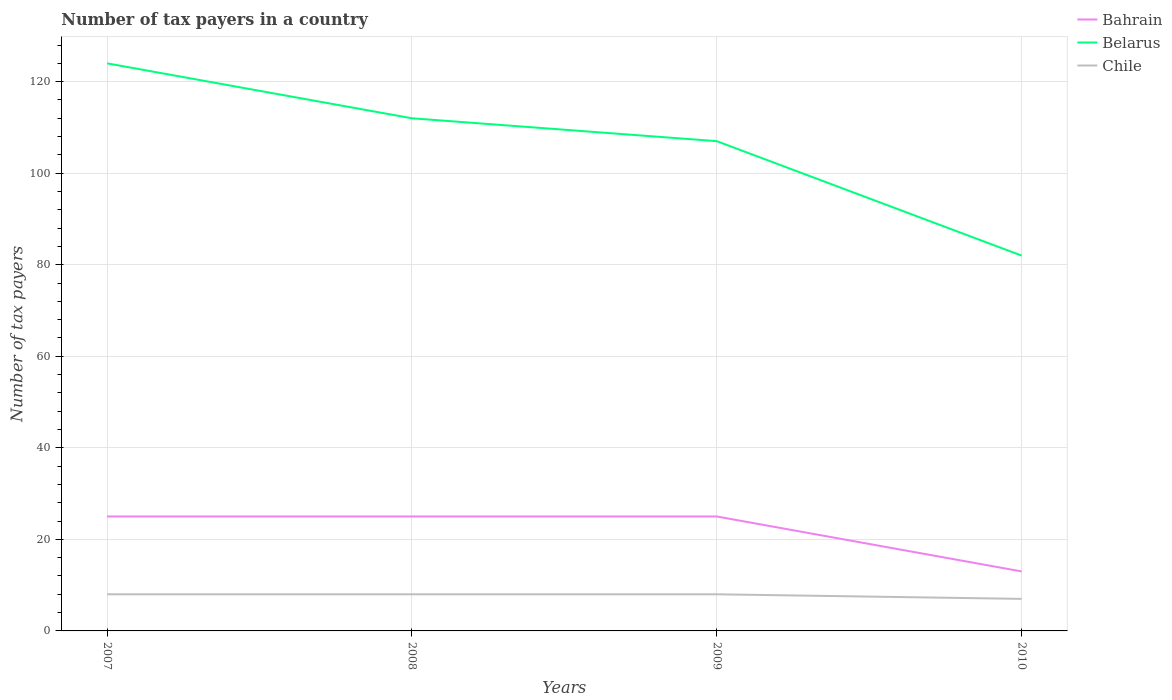Does the line corresponding to Belarus intersect with the line corresponding to Chile?
Offer a very short reply. No. Across all years, what is the maximum number of tax payers in in Bahrain?
Make the answer very short. 13. What is the total number of tax payers in in Belarus in the graph?
Your answer should be compact. 42. Is the number of tax payers in in Chile strictly greater than the number of tax payers in in Belarus over the years?
Give a very brief answer. Yes. Where does the legend appear in the graph?
Provide a short and direct response. Top right. How many legend labels are there?
Your response must be concise. 3. What is the title of the graph?
Provide a short and direct response. Number of tax payers in a country. What is the label or title of the Y-axis?
Provide a short and direct response. Number of tax payers. What is the Number of tax payers of Belarus in 2007?
Offer a very short reply. 124. What is the Number of tax payers in Chile in 2007?
Give a very brief answer. 8. What is the Number of tax payers in Bahrain in 2008?
Offer a very short reply. 25. What is the Number of tax payers of Belarus in 2008?
Provide a short and direct response. 112. What is the Number of tax payers in Belarus in 2009?
Make the answer very short. 107. What is the Number of tax payers in Belarus in 2010?
Your answer should be very brief. 82. What is the Number of tax payers in Chile in 2010?
Make the answer very short. 7. Across all years, what is the maximum Number of tax payers in Bahrain?
Ensure brevity in your answer.  25. Across all years, what is the maximum Number of tax payers of Belarus?
Provide a succinct answer. 124. Across all years, what is the maximum Number of tax payers in Chile?
Provide a succinct answer. 8. Across all years, what is the minimum Number of tax payers in Bahrain?
Offer a terse response. 13. Across all years, what is the minimum Number of tax payers in Belarus?
Provide a succinct answer. 82. What is the total Number of tax payers in Bahrain in the graph?
Provide a short and direct response. 88. What is the total Number of tax payers of Belarus in the graph?
Keep it short and to the point. 425. What is the difference between the Number of tax payers in Bahrain in 2007 and that in 2008?
Ensure brevity in your answer.  0. What is the difference between the Number of tax payers in Chile in 2007 and that in 2009?
Make the answer very short. 0. What is the difference between the Number of tax payers in Belarus in 2008 and that in 2010?
Offer a very short reply. 30. What is the difference between the Number of tax payers in Bahrain in 2007 and the Number of tax payers in Belarus in 2008?
Make the answer very short. -87. What is the difference between the Number of tax payers of Belarus in 2007 and the Number of tax payers of Chile in 2008?
Your response must be concise. 116. What is the difference between the Number of tax payers of Bahrain in 2007 and the Number of tax payers of Belarus in 2009?
Make the answer very short. -82. What is the difference between the Number of tax payers of Bahrain in 2007 and the Number of tax payers of Chile in 2009?
Give a very brief answer. 17. What is the difference between the Number of tax payers in Belarus in 2007 and the Number of tax payers in Chile in 2009?
Provide a short and direct response. 116. What is the difference between the Number of tax payers of Bahrain in 2007 and the Number of tax payers of Belarus in 2010?
Your answer should be very brief. -57. What is the difference between the Number of tax payers of Bahrain in 2007 and the Number of tax payers of Chile in 2010?
Make the answer very short. 18. What is the difference between the Number of tax payers of Belarus in 2007 and the Number of tax payers of Chile in 2010?
Provide a succinct answer. 117. What is the difference between the Number of tax payers of Bahrain in 2008 and the Number of tax payers of Belarus in 2009?
Ensure brevity in your answer.  -82. What is the difference between the Number of tax payers of Belarus in 2008 and the Number of tax payers of Chile in 2009?
Provide a short and direct response. 104. What is the difference between the Number of tax payers in Bahrain in 2008 and the Number of tax payers in Belarus in 2010?
Offer a terse response. -57. What is the difference between the Number of tax payers of Belarus in 2008 and the Number of tax payers of Chile in 2010?
Your response must be concise. 105. What is the difference between the Number of tax payers of Bahrain in 2009 and the Number of tax payers of Belarus in 2010?
Give a very brief answer. -57. What is the difference between the Number of tax payers of Belarus in 2009 and the Number of tax payers of Chile in 2010?
Make the answer very short. 100. What is the average Number of tax payers of Bahrain per year?
Provide a succinct answer. 22. What is the average Number of tax payers of Belarus per year?
Ensure brevity in your answer.  106.25. What is the average Number of tax payers in Chile per year?
Provide a succinct answer. 7.75. In the year 2007, what is the difference between the Number of tax payers of Bahrain and Number of tax payers of Belarus?
Your answer should be compact. -99. In the year 2007, what is the difference between the Number of tax payers in Belarus and Number of tax payers in Chile?
Provide a succinct answer. 116. In the year 2008, what is the difference between the Number of tax payers in Bahrain and Number of tax payers in Belarus?
Offer a terse response. -87. In the year 2008, what is the difference between the Number of tax payers in Bahrain and Number of tax payers in Chile?
Keep it short and to the point. 17. In the year 2008, what is the difference between the Number of tax payers of Belarus and Number of tax payers of Chile?
Give a very brief answer. 104. In the year 2009, what is the difference between the Number of tax payers of Bahrain and Number of tax payers of Belarus?
Ensure brevity in your answer.  -82. In the year 2009, what is the difference between the Number of tax payers of Bahrain and Number of tax payers of Chile?
Your answer should be very brief. 17. In the year 2009, what is the difference between the Number of tax payers of Belarus and Number of tax payers of Chile?
Keep it short and to the point. 99. In the year 2010, what is the difference between the Number of tax payers of Bahrain and Number of tax payers of Belarus?
Offer a very short reply. -69. In the year 2010, what is the difference between the Number of tax payers in Belarus and Number of tax payers in Chile?
Offer a very short reply. 75. What is the ratio of the Number of tax payers of Belarus in 2007 to that in 2008?
Offer a terse response. 1.11. What is the ratio of the Number of tax payers of Belarus in 2007 to that in 2009?
Keep it short and to the point. 1.16. What is the ratio of the Number of tax payers of Chile in 2007 to that in 2009?
Your response must be concise. 1. What is the ratio of the Number of tax payers in Bahrain in 2007 to that in 2010?
Provide a succinct answer. 1.92. What is the ratio of the Number of tax payers of Belarus in 2007 to that in 2010?
Provide a succinct answer. 1.51. What is the ratio of the Number of tax payers in Chile in 2007 to that in 2010?
Your answer should be very brief. 1.14. What is the ratio of the Number of tax payers of Bahrain in 2008 to that in 2009?
Keep it short and to the point. 1. What is the ratio of the Number of tax payers in Belarus in 2008 to that in 2009?
Give a very brief answer. 1.05. What is the ratio of the Number of tax payers of Bahrain in 2008 to that in 2010?
Give a very brief answer. 1.92. What is the ratio of the Number of tax payers in Belarus in 2008 to that in 2010?
Offer a very short reply. 1.37. What is the ratio of the Number of tax payers of Bahrain in 2009 to that in 2010?
Provide a succinct answer. 1.92. What is the ratio of the Number of tax payers of Belarus in 2009 to that in 2010?
Your answer should be very brief. 1.3. What is the difference between the highest and the second highest Number of tax payers in Bahrain?
Provide a short and direct response. 0. What is the difference between the highest and the second highest Number of tax payers in Belarus?
Make the answer very short. 12. What is the difference between the highest and the lowest Number of tax payers in Belarus?
Provide a short and direct response. 42. 